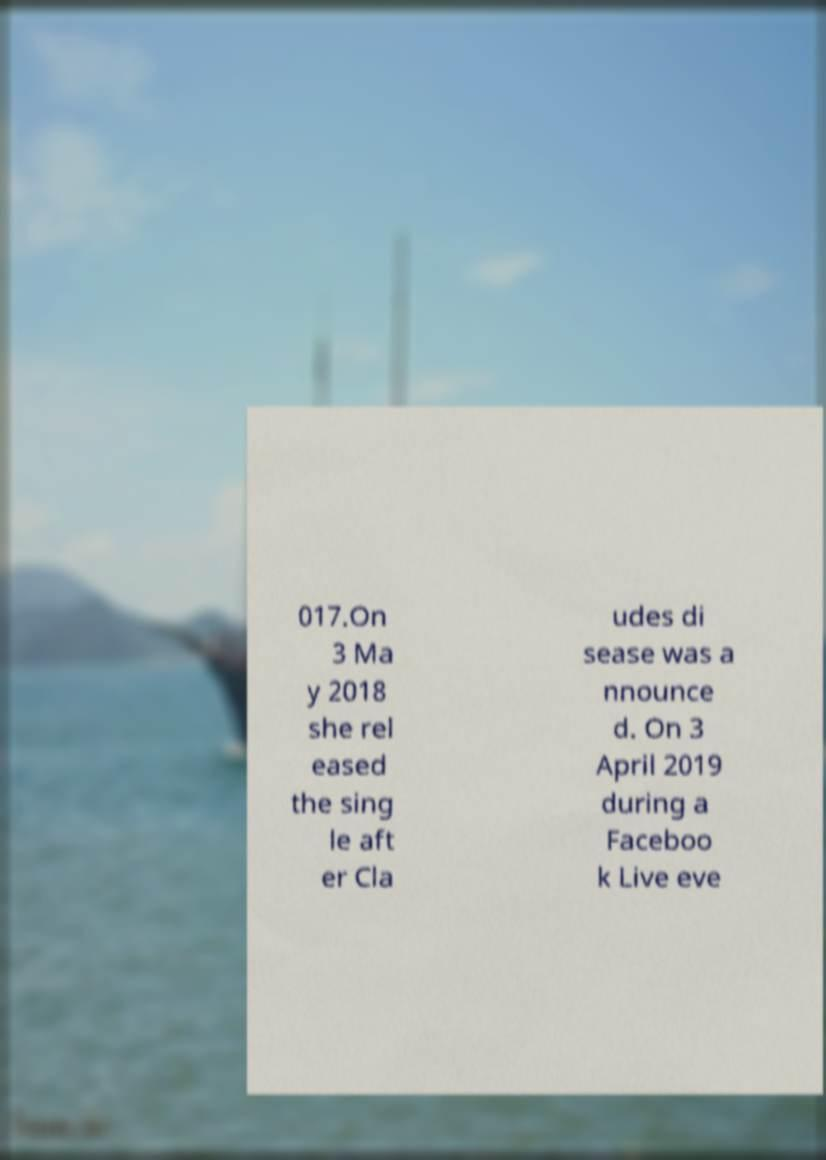For documentation purposes, I need the text within this image transcribed. Could you provide that? 017.On 3 Ma y 2018 she rel eased the sing le aft er Cla udes di sease was a nnounce d. On 3 April 2019 during a Faceboo k Live eve 